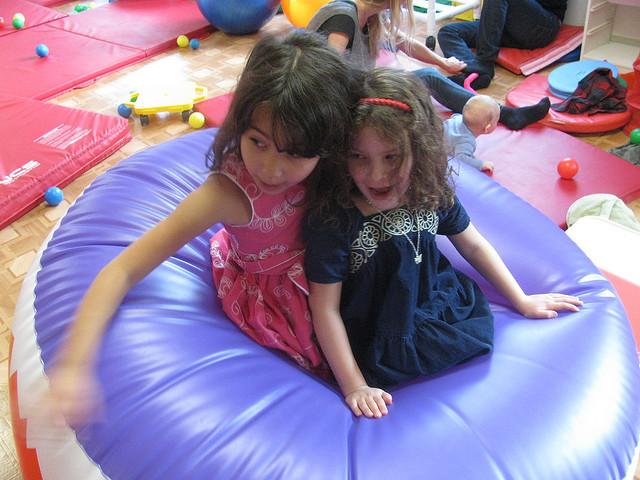Is this a playground?
Give a very brief answer. No. What are the girls playing in?
Write a very short answer. Tube. How many boys are here?
Short answer required. 0. 